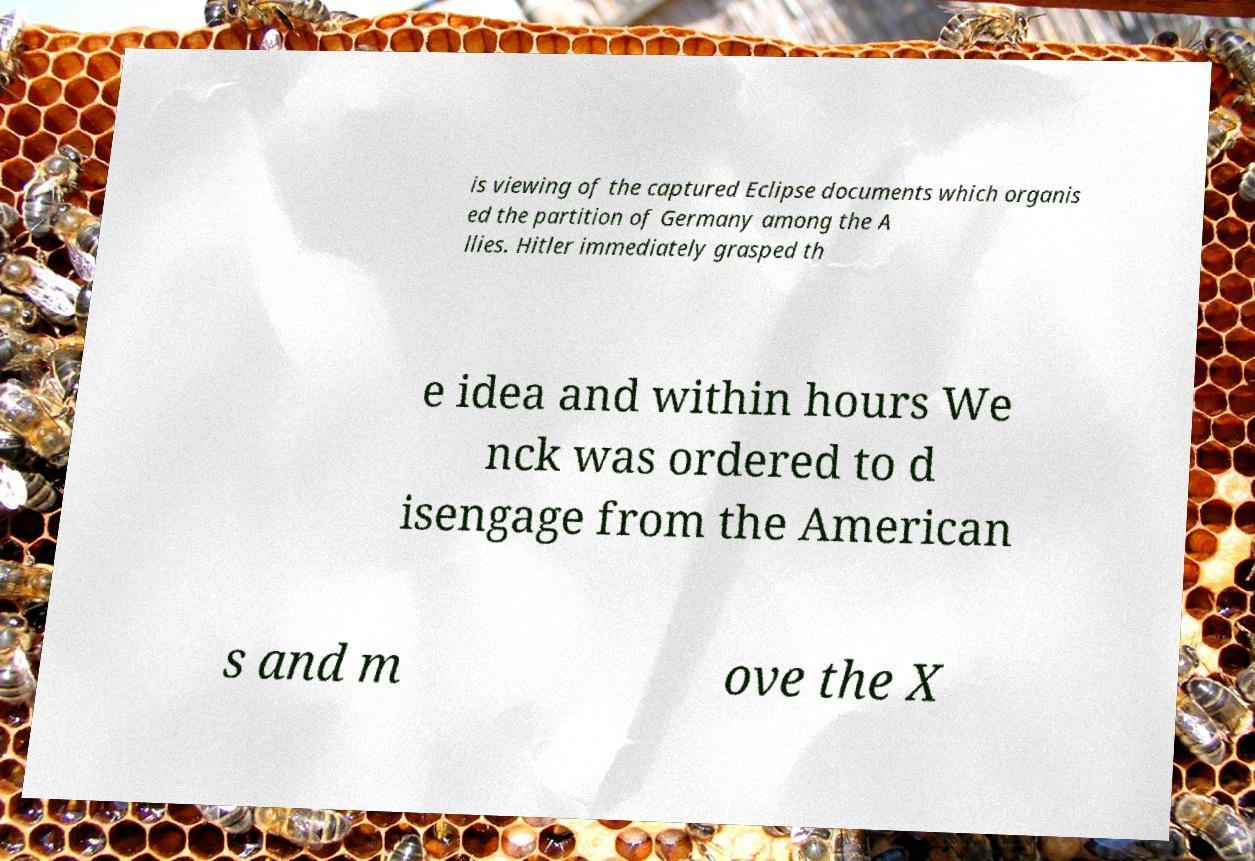I need the written content from this picture converted into text. Can you do that? is viewing of the captured Eclipse documents which organis ed the partition of Germany among the A llies. Hitler immediately grasped th e idea and within hours We nck was ordered to d isengage from the American s and m ove the X 